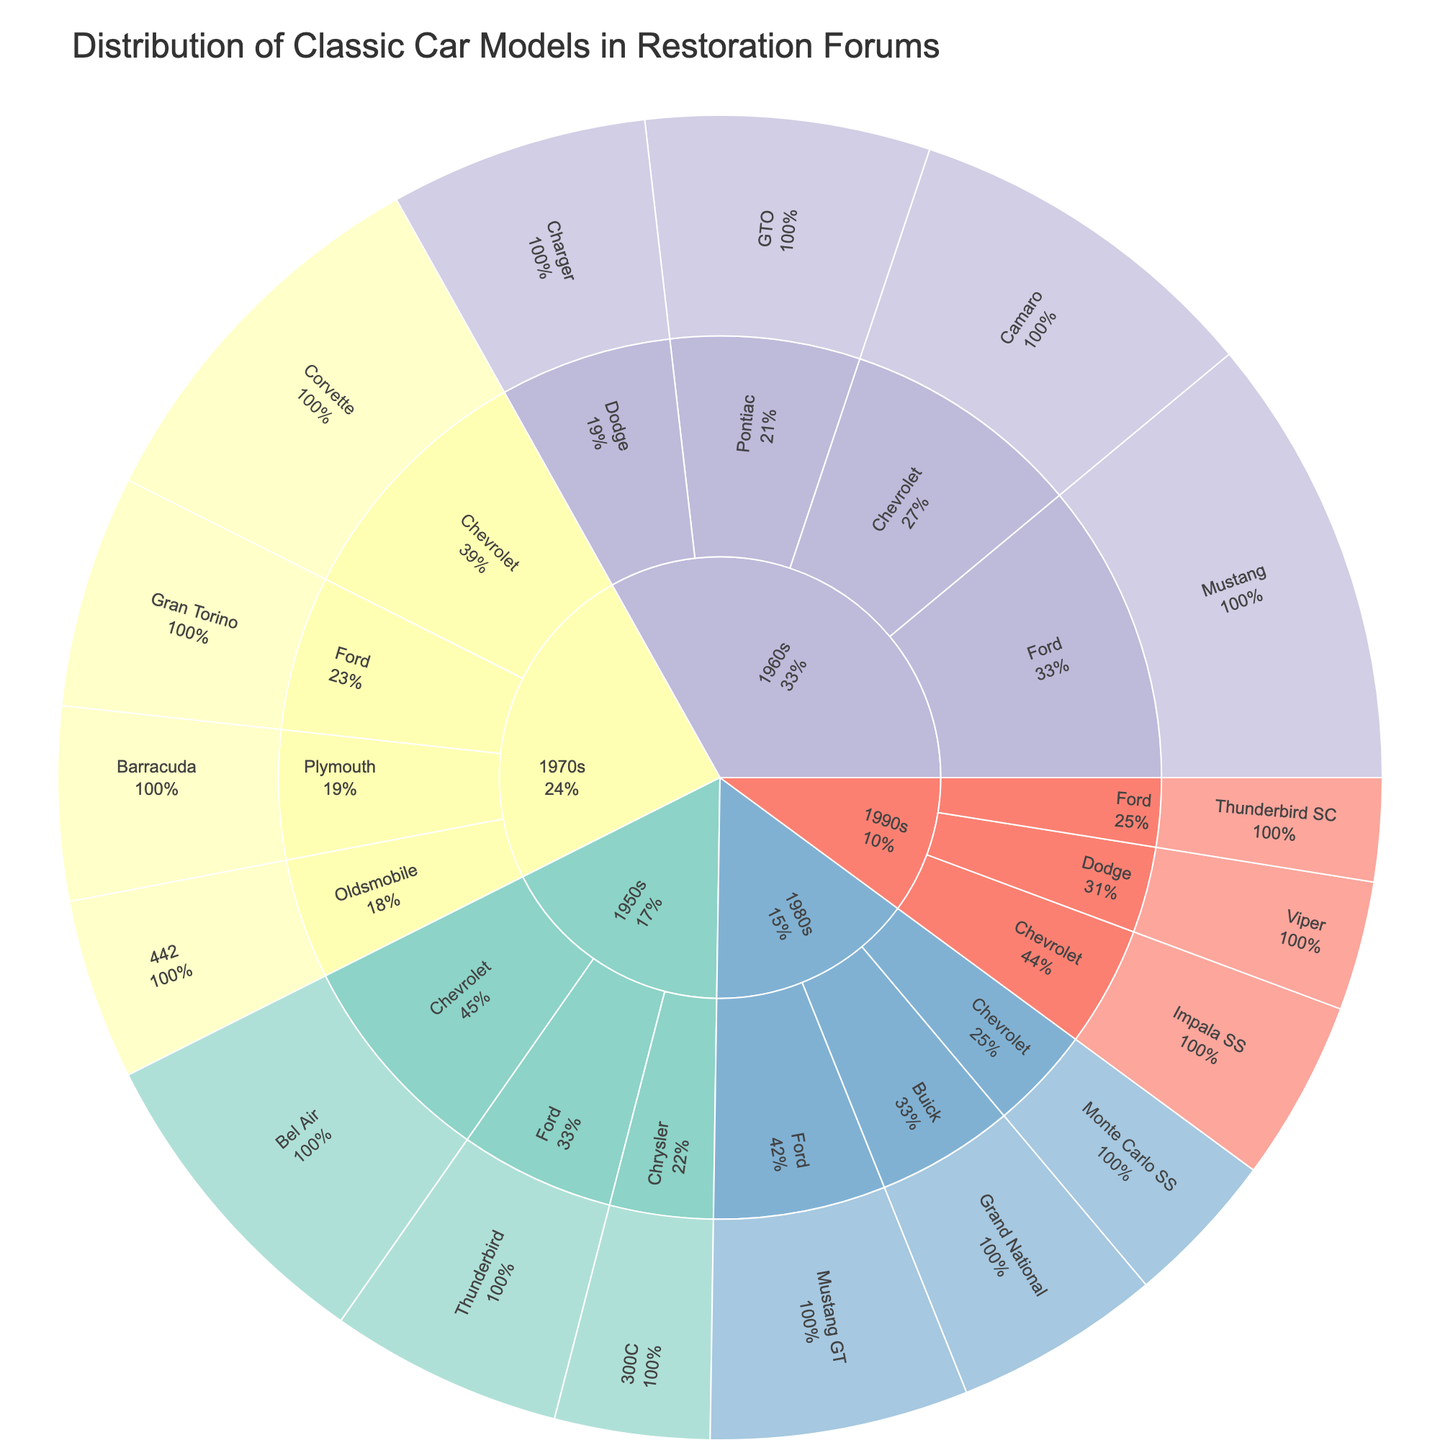What's the most popular classic car model in the 1960s decade? Observe the section labeled "1960s" in the Sunburst Plot and identify which model has the largest portion within that section. The Mustang by Ford is the most popular as it occupies the largest area.
Answer: Ford Mustang What is the combined value of classic car models from Chevrolet across all decades? Examine the sections labeled with Chevrolet and sum their values. For the 1950s, Chevrolet Bel Air has a value of 25; for the 1960s, Chevrolet Camaro has a value of 28; and for the 1970s, Chevrolet Corvette has a value of 30. Adding these, 25 + 28 + 30 = 83.
Answer: 83 Which decade has the most diverse range of manufacturers represented? Count the distinct manufacturers under each decade in the Sunburst Plot. The 1960s have the greatest diversity with Ford, Chevrolet, Pontiac, and Dodge represented.
Answer: 1960s How does the popularity of Ford Thunderbird change from the 1950s to the 1990s? First, identify the value of the Ford Thunderbird in the 1950s (18) and compare it to the value of the Ford Thunderbird SC in the 1990s (8). The value decreases from 18 to 8.
Answer: Decreases Which decade has the smallest total value when all its models are summed? Sum the values for each decade and compare. For the 1950s, the total is 25 + 18 + 12 = 55. For the 1960s, it's 35 + 28 + 22 + 20 = 105. For the 1970s, it's 15 + 30 + 18 + 14 = 77. For the 1980s, it's 16 + 12 + 20 = 48. For the 1990s, it’s 10 + 14 + 8 = 32. The 1990s has the smallest total value.
Answer: 1990s Which manufacturer is most consistently represented across multiple decades? Look at the manufacturers present in the plot and see how many decades each appears in. Chevrolet appears in four decades (1950s, 1960s, 1970s, and 1990s), making it the most consistent.
Answer: Chevrolet What percentage of the total classic car model representation does the 1960s decade hold? Sum the total values from all decades, then find out the total for the 1960s, and calculate the percentage. Total = 55 + 105 + 77 + 48 + 32 = 317. The total for the 1960s is 105. (105 / 317) * 100 ≈ 33.1%
Answer: 33.1% How many models are there in the 1970s with a value greater than 14? Identify the models under the 1970s section, then count those with a value greater than 14. They are the Chevrolet Corvette (30), the Ford Gran Torino (18). So the count is 2.
Answer: 2 Which Ford model has the highest value regardless of the decade? Identify all Ford models from the plot and compare their values. The Ford Mustang from the 1960s has the highest value at 35.
Answer: Ford Mustang What is the difference in value between the Chevrolet Corvette in the 1970s and the Dodge Charger in the 1960s? Identify the values for both models and compute the difference. Chevrolet Corvette from the 1970s has a value of 30, and Dodge Charger from the 1960s has a value of 20. The difference is 30 - 20 = 10.
Answer: 10 